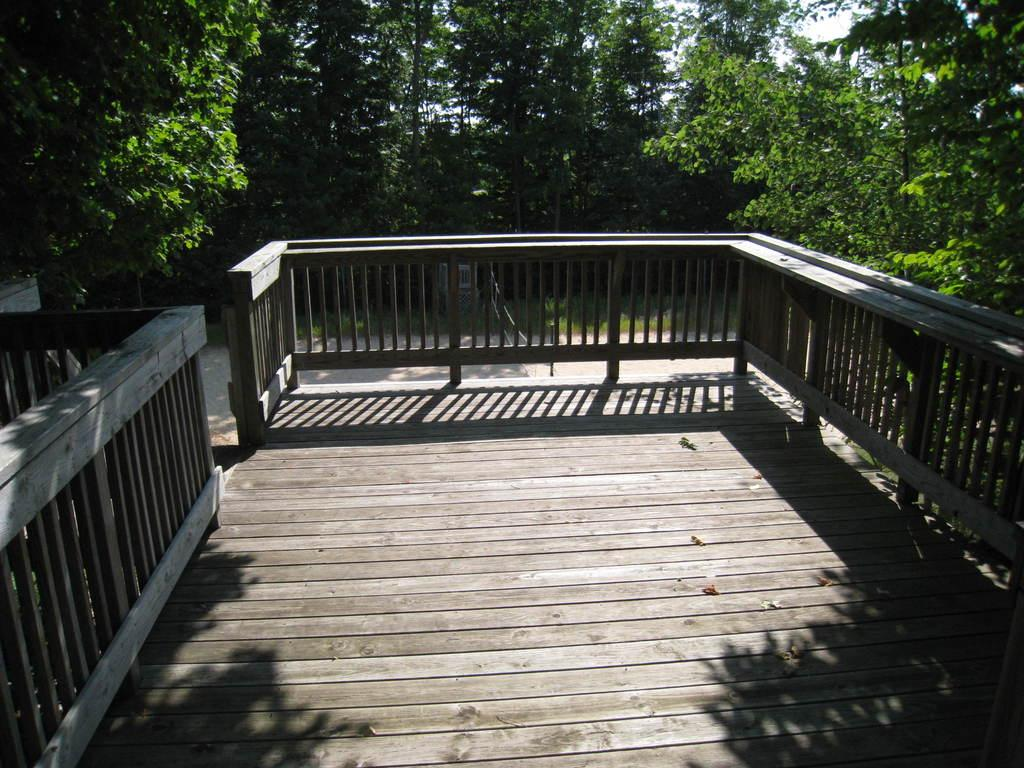What type of flooring is present in the image? There is a wooden floor in the image. What other wooden structure can be seen in the image? There is a wooden fence in the image. What is located behind the wooden fence? Trees are visible behind the fence. What part of the natural environment is visible in the image? The sky is visible in the image. Can you see a wave crashing on the shore in the image? There is no wave or shore present in the image; it features a wooden floor, wooden fence, trees, and the sky. Is there a cactus visible in the image? There is no cactus present in the image. 